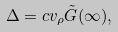Convert formula to latex. <formula><loc_0><loc_0><loc_500><loc_500>\Delta = c v _ { \rho } \tilde { G } ( \infty ) ,</formula> 